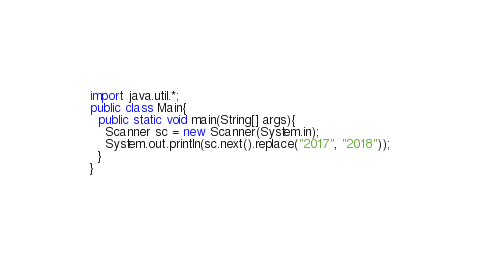<code> <loc_0><loc_0><loc_500><loc_500><_Java_>import java.util.*;
public class Main{
  public static void main(String[] args){
    Scanner sc = new Scanner(System.in);
    System.out.println(sc.next().replace("2017", "2018"));
  }
}</code> 